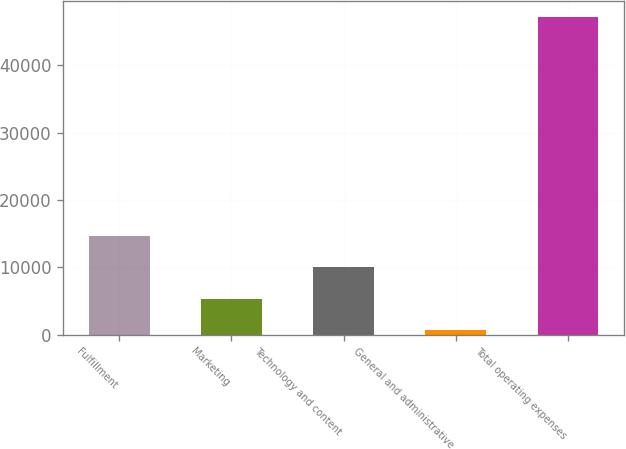Convert chart. <chart><loc_0><loc_0><loc_500><loc_500><bar_chart><fcel>Fulfillment<fcel>Marketing<fcel>Technology and content<fcel>General and administrative<fcel>Total operating expenses<nl><fcel>14625.1<fcel>5313.7<fcel>9969.4<fcel>658<fcel>47215<nl></chart> 